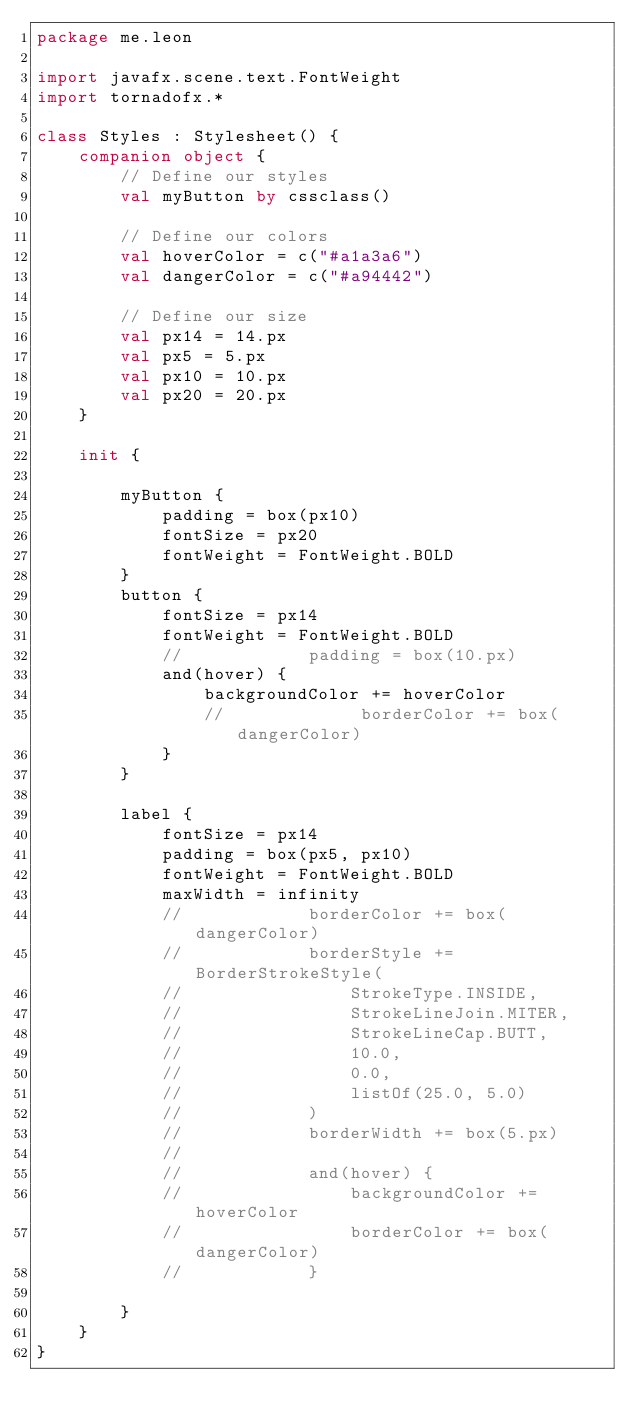<code> <loc_0><loc_0><loc_500><loc_500><_Kotlin_>package me.leon

import javafx.scene.text.FontWeight
import tornadofx.*

class Styles : Stylesheet() {
    companion object {
        // Define our styles
        val myButton by cssclass()

        // Define our colors
        val hoverColor = c("#a1a3a6")
        val dangerColor = c("#a94442")

        // Define our size
        val px14 = 14.px
        val px5 = 5.px
        val px10 = 10.px
        val px20 = 20.px
    }

    init {

        myButton {
            padding = box(px10)
            fontSize = px20
            fontWeight = FontWeight.BOLD
        }
        button {
            fontSize = px14
            fontWeight = FontWeight.BOLD
            //            padding = box(10.px)
            and(hover) {
                backgroundColor += hoverColor
                //             borderColor += box(dangerColor)
            }
        }

        label {
            fontSize = px14
            padding = box(px5, px10)
            fontWeight = FontWeight.BOLD
            maxWidth = infinity
            //            borderColor += box(dangerColor)
            //            borderStyle += BorderStrokeStyle(
            //                StrokeType.INSIDE,
            //                StrokeLineJoin.MITER,
            //                StrokeLineCap.BUTT,
            //                10.0,
            //                0.0,
            //                listOf(25.0, 5.0)
            //            )
            //            borderWidth += box(5.px)
            //
            //            and(hover) {
            //                backgroundColor += hoverColor
            //                borderColor += box(dangerColor)
            //            }

        }
    }
}
</code> 